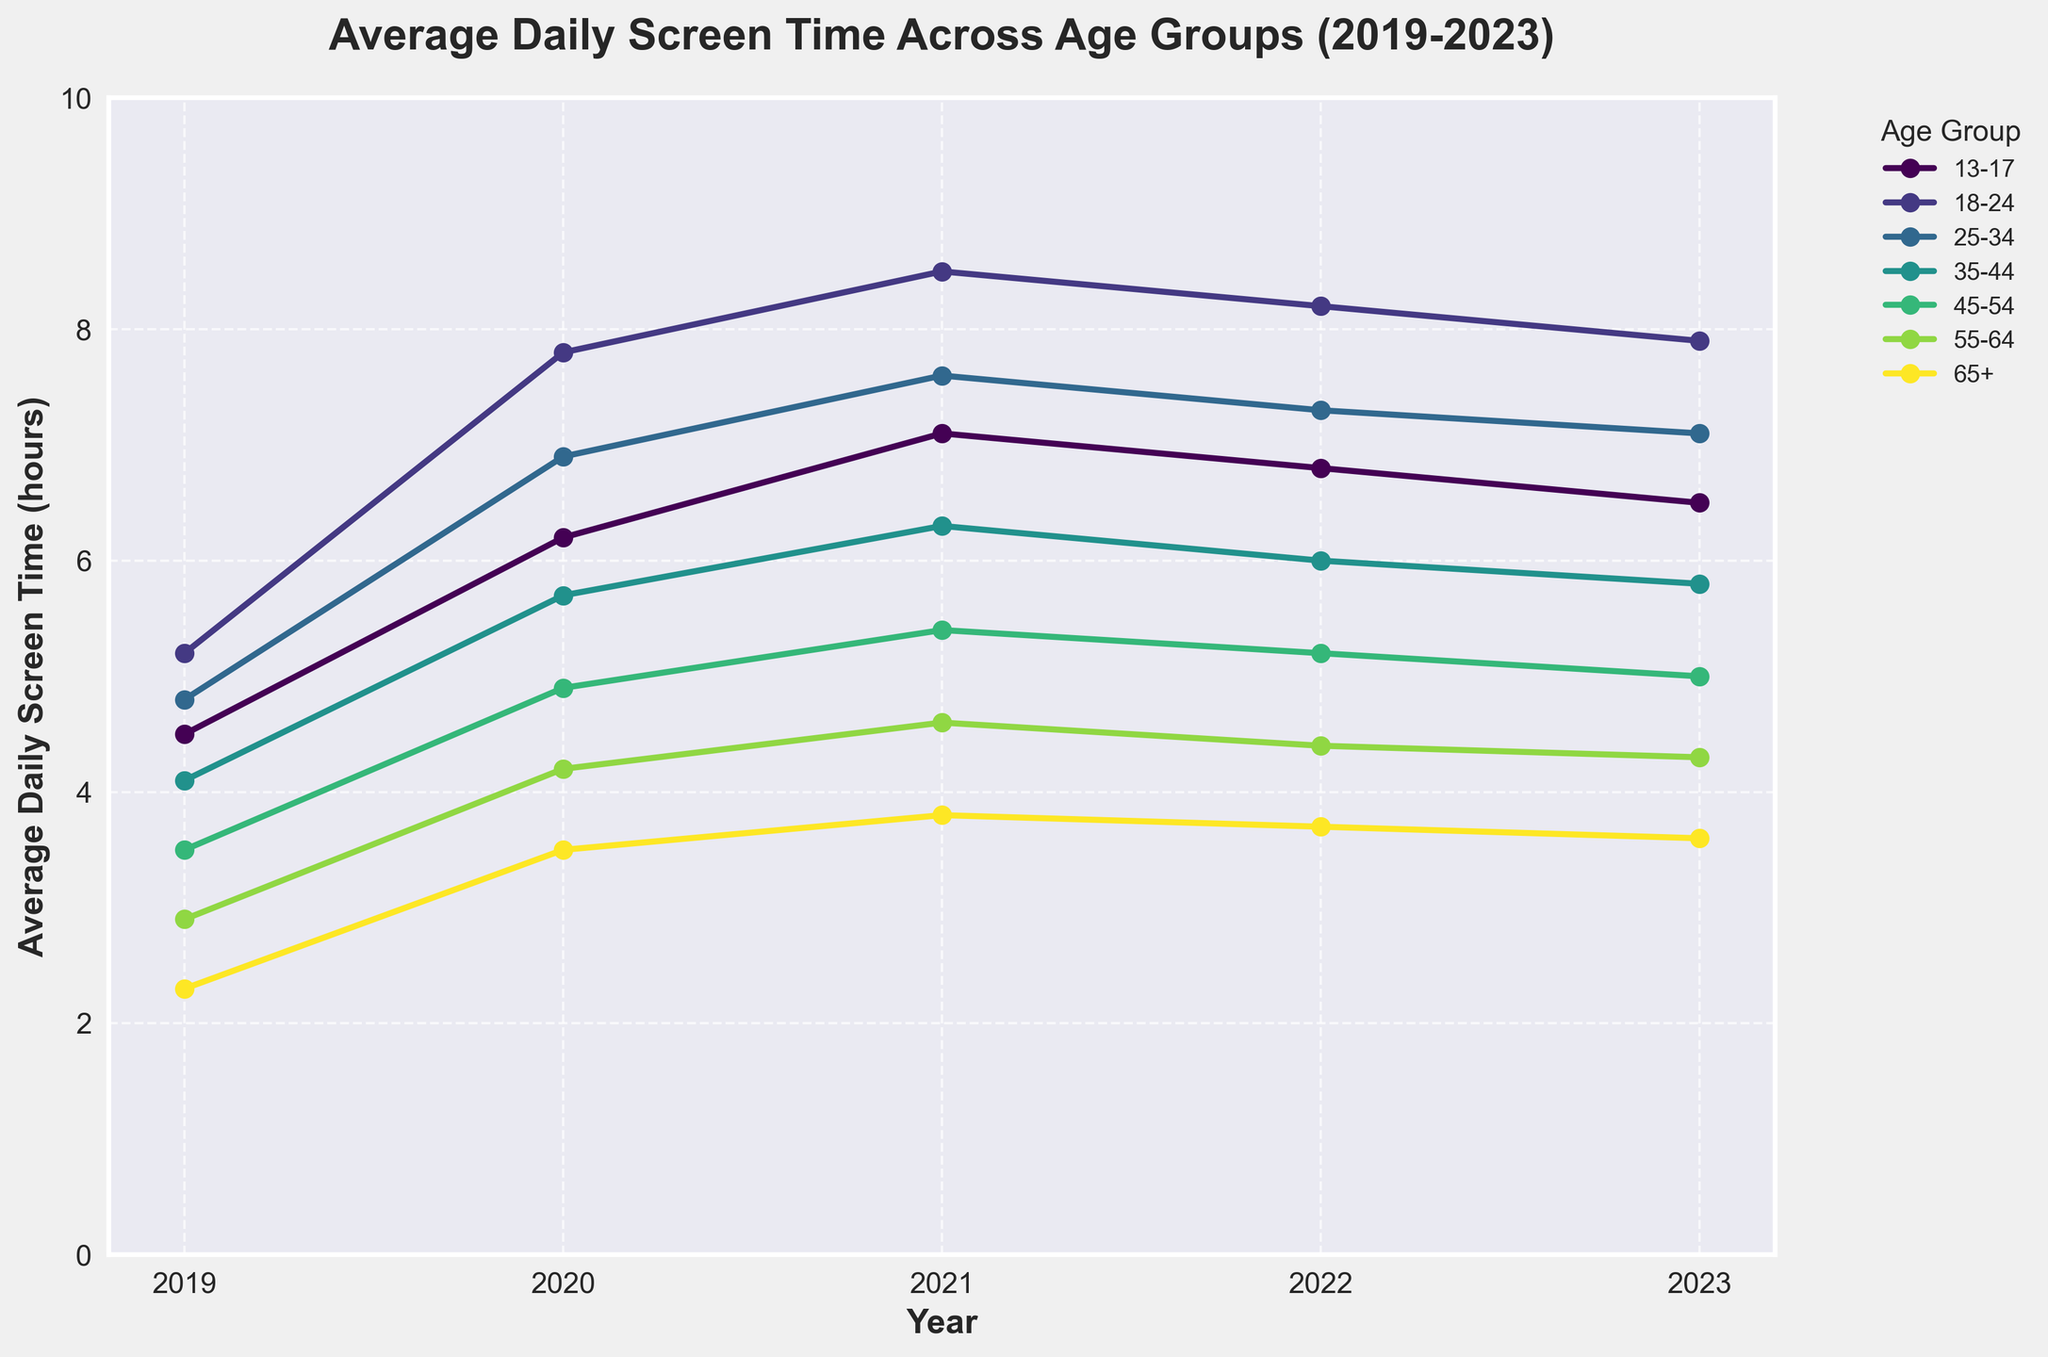Which age group had the highest average daily screen time in 2021? In 2021, the graph shows that the age group 18-24 had the highest screen time, peaking around 8.5 hours, which is the tallest marker for that year.
Answer: 18-24 How did the average daily screen time for the 35-44 age group change from 2019 to 2023? Looking at the graph, in 2019 it was about 4.1 hours and in 2023 it was 5.8 hours. The change in screen time is the difference between these two values: 5.8 - 4.1 = 1.7 hours.
Answer: Increased by 1.7 hours Which age group saw the largest increase in average daily screen time from 2019 to 2020? To determine this, compare each age group's change from 2019 to 2020. The 18-24 group increased from 5.2 to 7.8, which is a 2.6-hour increase, the highest among all age groups.
Answer: 18-24 In 2023, which age group had the smallest average daily screen time? For 2023, the smallest marker on the graph belongs to the 65+ age group, which is around 3.6 hours.
Answer: 65+ How much did the average daily screen time for the 55-64 age group increase from 2019 to 2021? The screen time for the 55-64 age group in 2019 was 2.9 hours, and in 2021 was 4.6 hours. The increase is 4.6 - 2.9 = 1.7 hours.
Answer: 1.7 hours Which age groups saw a decrease in average daily screen time from 2021 to 2023? From 2021 to 2023, observe the trend lines for each age group. The 13-17, 18-24, 25-34, 35-44, and 45-54 age groups exhibited decreasing trends.
Answer: 13-17, 18-24, 25-34, 35-44, 45-54 Did any age group have a steady increase in average daily screen time from 2019 to 2023? Looking at the trend lines, the elder age group 65+ saw a gradual, consistent increase in screen time every year from 2019 (2.3 hours) to 2023 (3.6 hours).
Answer: 65+ Which year had the most significant overall increase in screen time across all age groups? Comparing the overall rises in screen time across all age groups between consecutive years, the sharp increase from 2019 to 2020 is evident for all age groups.
Answer: 2020 What was the approximate difference in screen time between the 18-24 and 65+ age groups in 2020? In 2020, the 18-24 age group had about 7.8 hours, and the 65+ group had about 3.5 hours. The difference is roughly 7.8 - 3.5 = 4.3 hours.
Answer: 4.3 hours How did screen time for the 45-54 age group trend from 2021 to 2023? For the 45-54 age group, the data points indicate a decreasing trend: from 5.4 hours in 2021 to 5.2 hours in 2022, and further down to 5.0 hours in 2023.
Answer: Decreased 